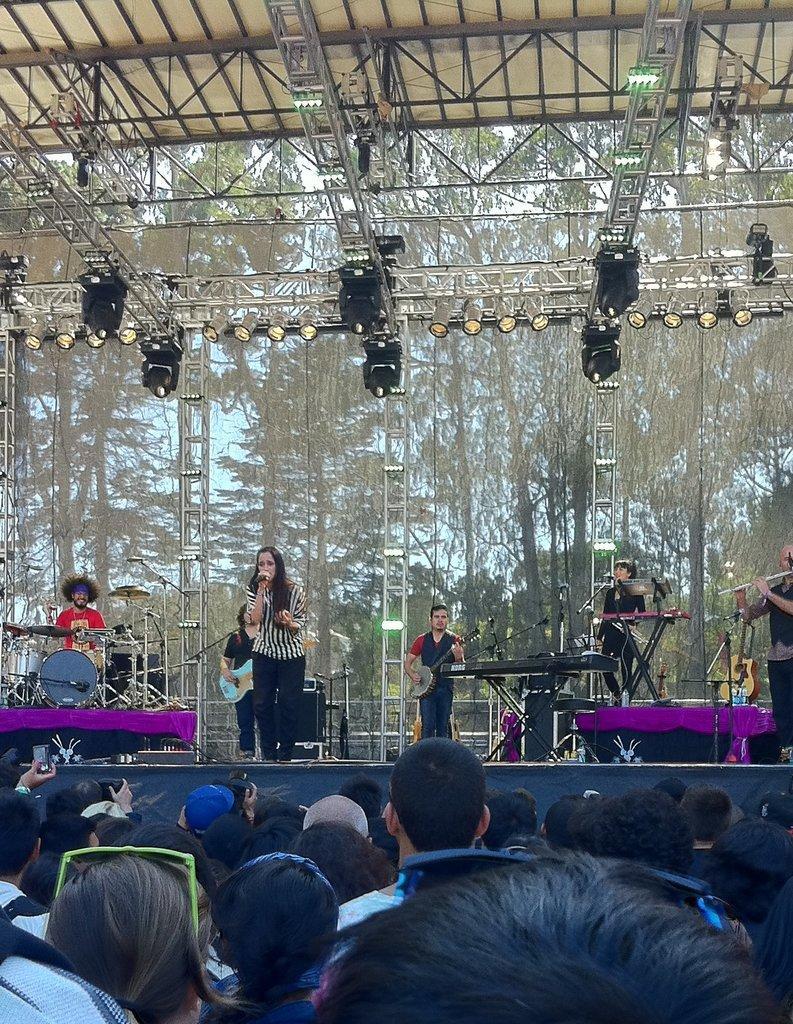In one or two sentences, can you explain what this image depicts? In this picture we can see there are some people standing on the path and some people are standing on the stage. Some people playing the musical instruments and a woman is holding a microphone. At the top there are lights and other objects and behind the people there are trees and the sky. 